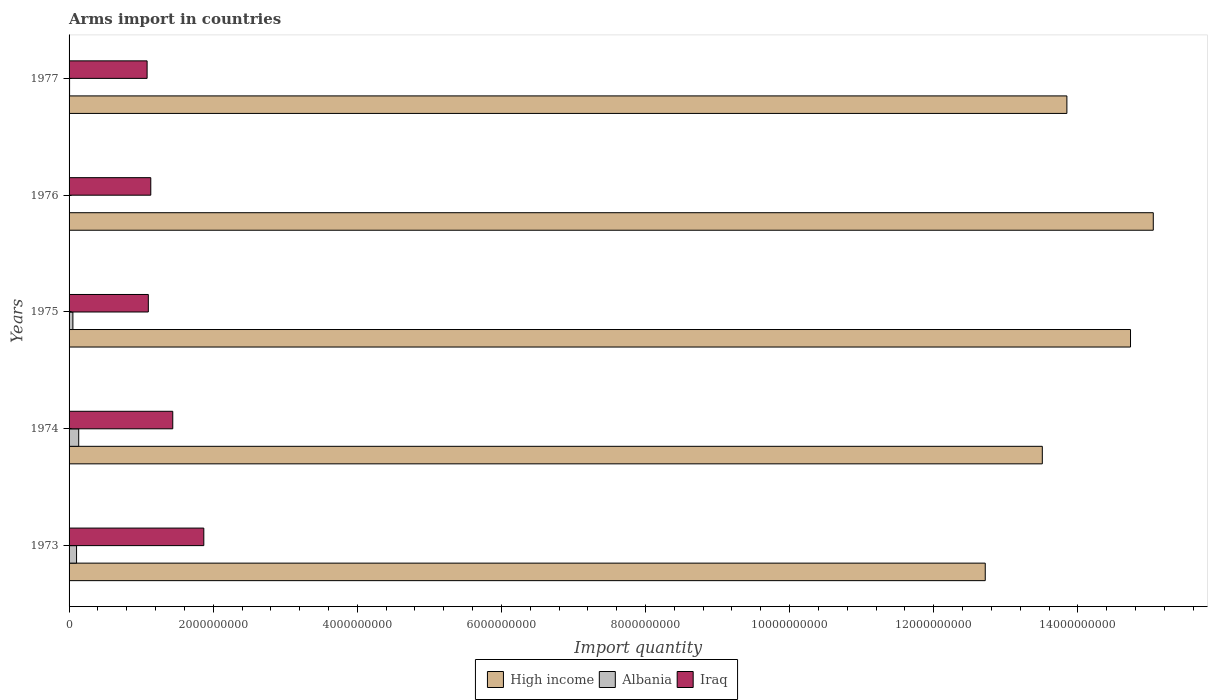How many groups of bars are there?
Your answer should be compact. 5. How many bars are there on the 5th tick from the top?
Provide a short and direct response. 3. How many bars are there on the 4th tick from the bottom?
Offer a terse response. 3. What is the label of the 4th group of bars from the top?
Your answer should be compact. 1974. In how many cases, is the number of bars for a given year not equal to the number of legend labels?
Make the answer very short. 0. What is the total arms import in High income in 1975?
Your answer should be compact. 1.47e+1. Across all years, what is the maximum total arms import in Iraq?
Your answer should be compact. 1.87e+09. Across all years, what is the minimum total arms import in High income?
Offer a terse response. 1.27e+1. In which year was the total arms import in Iraq maximum?
Keep it short and to the point. 1973. In which year was the total arms import in Albania minimum?
Offer a terse response. 1976. What is the total total arms import in High income in the graph?
Give a very brief answer. 6.98e+1. What is the difference between the total arms import in High income in 1973 and that in 1977?
Give a very brief answer. -1.13e+09. What is the difference between the total arms import in Iraq in 1977 and the total arms import in Albania in 1973?
Give a very brief answer. 9.79e+08. What is the average total arms import in Iraq per year?
Make the answer very short. 1.33e+09. In the year 1976, what is the difference between the total arms import in Iraq and total arms import in High income?
Provide a succinct answer. -1.39e+1. In how many years, is the total arms import in High income greater than 11600000000 ?
Ensure brevity in your answer.  5. What is the ratio of the total arms import in Albania in 1975 to that in 1976?
Ensure brevity in your answer.  10.6. What is the difference between the highest and the second highest total arms import in Albania?
Offer a very short reply. 3.00e+07. What is the difference between the highest and the lowest total arms import in High income?
Ensure brevity in your answer.  2.33e+09. In how many years, is the total arms import in Albania greater than the average total arms import in Albania taken over all years?
Your answer should be very brief. 2. What does the 1st bar from the top in 1973 represents?
Provide a short and direct response. Iraq. Is it the case that in every year, the sum of the total arms import in Iraq and total arms import in Albania is greater than the total arms import in High income?
Your answer should be compact. No. How many bars are there?
Provide a short and direct response. 15. Are all the bars in the graph horizontal?
Offer a terse response. Yes. Does the graph contain grids?
Keep it short and to the point. No. Where does the legend appear in the graph?
Make the answer very short. Bottom center. What is the title of the graph?
Your answer should be very brief. Arms import in countries. What is the label or title of the X-axis?
Ensure brevity in your answer.  Import quantity. What is the label or title of the Y-axis?
Your answer should be very brief. Years. What is the Import quantity in High income in 1973?
Provide a succinct answer. 1.27e+1. What is the Import quantity in Albania in 1973?
Provide a short and direct response. 1.04e+08. What is the Import quantity of Iraq in 1973?
Your response must be concise. 1.87e+09. What is the Import quantity of High income in 1974?
Your answer should be very brief. 1.35e+1. What is the Import quantity in Albania in 1974?
Your answer should be very brief. 1.34e+08. What is the Import quantity of Iraq in 1974?
Make the answer very short. 1.44e+09. What is the Import quantity of High income in 1975?
Provide a succinct answer. 1.47e+1. What is the Import quantity of Albania in 1975?
Give a very brief answer. 5.30e+07. What is the Import quantity of Iraq in 1975?
Your answer should be compact. 1.10e+09. What is the Import quantity of High income in 1976?
Give a very brief answer. 1.50e+1. What is the Import quantity in Iraq in 1976?
Make the answer very short. 1.13e+09. What is the Import quantity in High income in 1977?
Your answer should be very brief. 1.38e+1. What is the Import quantity in Albania in 1977?
Your answer should be very brief. 7.00e+06. What is the Import quantity of Iraq in 1977?
Provide a succinct answer. 1.08e+09. Across all years, what is the maximum Import quantity of High income?
Offer a terse response. 1.50e+1. Across all years, what is the maximum Import quantity in Albania?
Make the answer very short. 1.34e+08. Across all years, what is the maximum Import quantity in Iraq?
Your answer should be compact. 1.87e+09. Across all years, what is the minimum Import quantity in High income?
Provide a short and direct response. 1.27e+1. Across all years, what is the minimum Import quantity of Albania?
Ensure brevity in your answer.  5.00e+06. Across all years, what is the minimum Import quantity in Iraq?
Offer a terse response. 1.08e+09. What is the total Import quantity of High income in the graph?
Your answer should be compact. 6.98e+1. What is the total Import quantity in Albania in the graph?
Make the answer very short. 3.03e+08. What is the total Import quantity in Iraq in the graph?
Give a very brief answer. 6.63e+09. What is the difference between the Import quantity in High income in 1973 and that in 1974?
Offer a very short reply. -7.92e+08. What is the difference between the Import quantity of Albania in 1973 and that in 1974?
Keep it short and to the point. -3.00e+07. What is the difference between the Import quantity in Iraq in 1973 and that in 1974?
Ensure brevity in your answer.  4.31e+08. What is the difference between the Import quantity of High income in 1973 and that in 1975?
Make the answer very short. -2.02e+09. What is the difference between the Import quantity of Albania in 1973 and that in 1975?
Your answer should be very brief. 5.10e+07. What is the difference between the Import quantity of Iraq in 1973 and that in 1975?
Provide a short and direct response. 7.70e+08. What is the difference between the Import quantity in High income in 1973 and that in 1976?
Provide a short and direct response. -2.33e+09. What is the difference between the Import quantity of Albania in 1973 and that in 1976?
Offer a very short reply. 9.90e+07. What is the difference between the Import quantity of Iraq in 1973 and that in 1976?
Provide a succinct answer. 7.36e+08. What is the difference between the Import quantity of High income in 1973 and that in 1977?
Provide a short and direct response. -1.13e+09. What is the difference between the Import quantity of Albania in 1973 and that in 1977?
Provide a succinct answer. 9.70e+07. What is the difference between the Import quantity of Iraq in 1973 and that in 1977?
Keep it short and to the point. 7.87e+08. What is the difference between the Import quantity of High income in 1974 and that in 1975?
Keep it short and to the point. -1.22e+09. What is the difference between the Import quantity in Albania in 1974 and that in 1975?
Offer a very short reply. 8.10e+07. What is the difference between the Import quantity in Iraq in 1974 and that in 1975?
Your answer should be compact. 3.39e+08. What is the difference between the Import quantity in High income in 1974 and that in 1976?
Your answer should be very brief. -1.54e+09. What is the difference between the Import quantity of Albania in 1974 and that in 1976?
Keep it short and to the point. 1.29e+08. What is the difference between the Import quantity of Iraq in 1974 and that in 1976?
Offer a very short reply. 3.05e+08. What is the difference between the Import quantity of High income in 1974 and that in 1977?
Offer a very short reply. -3.41e+08. What is the difference between the Import quantity of Albania in 1974 and that in 1977?
Provide a succinct answer. 1.27e+08. What is the difference between the Import quantity in Iraq in 1974 and that in 1977?
Your response must be concise. 3.56e+08. What is the difference between the Import quantity in High income in 1975 and that in 1976?
Your response must be concise. -3.16e+08. What is the difference between the Import quantity in Albania in 1975 and that in 1976?
Your answer should be compact. 4.80e+07. What is the difference between the Import quantity in Iraq in 1975 and that in 1976?
Make the answer very short. -3.40e+07. What is the difference between the Import quantity of High income in 1975 and that in 1977?
Provide a succinct answer. 8.83e+08. What is the difference between the Import quantity of Albania in 1975 and that in 1977?
Provide a short and direct response. 4.60e+07. What is the difference between the Import quantity in Iraq in 1975 and that in 1977?
Keep it short and to the point. 1.70e+07. What is the difference between the Import quantity in High income in 1976 and that in 1977?
Ensure brevity in your answer.  1.20e+09. What is the difference between the Import quantity in Iraq in 1976 and that in 1977?
Keep it short and to the point. 5.10e+07. What is the difference between the Import quantity of High income in 1973 and the Import quantity of Albania in 1974?
Offer a very short reply. 1.26e+1. What is the difference between the Import quantity in High income in 1973 and the Import quantity in Iraq in 1974?
Give a very brief answer. 1.13e+1. What is the difference between the Import quantity in Albania in 1973 and the Import quantity in Iraq in 1974?
Give a very brief answer. -1.34e+09. What is the difference between the Import quantity in High income in 1973 and the Import quantity in Albania in 1975?
Provide a short and direct response. 1.27e+1. What is the difference between the Import quantity of High income in 1973 and the Import quantity of Iraq in 1975?
Your answer should be compact. 1.16e+1. What is the difference between the Import quantity of Albania in 1973 and the Import quantity of Iraq in 1975?
Offer a terse response. -9.96e+08. What is the difference between the Import quantity of High income in 1973 and the Import quantity of Albania in 1976?
Ensure brevity in your answer.  1.27e+1. What is the difference between the Import quantity of High income in 1973 and the Import quantity of Iraq in 1976?
Ensure brevity in your answer.  1.16e+1. What is the difference between the Import quantity in Albania in 1973 and the Import quantity in Iraq in 1976?
Keep it short and to the point. -1.03e+09. What is the difference between the Import quantity of High income in 1973 and the Import quantity of Albania in 1977?
Keep it short and to the point. 1.27e+1. What is the difference between the Import quantity in High income in 1973 and the Import quantity in Iraq in 1977?
Provide a succinct answer. 1.16e+1. What is the difference between the Import quantity of Albania in 1973 and the Import quantity of Iraq in 1977?
Provide a succinct answer. -9.79e+08. What is the difference between the Import quantity of High income in 1974 and the Import quantity of Albania in 1975?
Offer a terse response. 1.35e+1. What is the difference between the Import quantity of High income in 1974 and the Import quantity of Iraq in 1975?
Provide a succinct answer. 1.24e+1. What is the difference between the Import quantity of Albania in 1974 and the Import quantity of Iraq in 1975?
Offer a very short reply. -9.66e+08. What is the difference between the Import quantity of High income in 1974 and the Import quantity of Albania in 1976?
Your answer should be compact. 1.35e+1. What is the difference between the Import quantity in High income in 1974 and the Import quantity in Iraq in 1976?
Ensure brevity in your answer.  1.24e+1. What is the difference between the Import quantity of Albania in 1974 and the Import quantity of Iraq in 1976?
Keep it short and to the point. -1.00e+09. What is the difference between the Import quantity in High income in 1974 and the Import quantity in Albania in 1977?
Your response must be concise. 1.35e+1. What is the difference between the Import quantity in High income in 1974 and the Import quantity in Iraq in 1977?
Provide a succinct answer. 1.24e+1. What is the difference between the Import quantity in Albania in 1974 and the Import quantity in Iraq in 1977?
Make the answer very short. -9.49e+08. What is the difference between the Import quantity of High income in 1975 and the Import quantity of Albania in 1976?
Offer a very short reply. 1.47e+1. What is the difference between the Import quantity of High income in 1975 and the Import quantity of Iraq in 1976?
Provide a succinct answer. 1.36e+1. What is the difference between the Import quantity of Albania in 1975 and the Import quantity of Iraq in 1976?
Provide a short and direct response. -1.08e+09. What is the difference between the Import quantity of High income in 1975 and the Import quantity of Albania in 1977?
Your answer should be very brief. 1.47e+1. What is the difference between the Import quantity in High income in 1975 and the Import quantity in Iraq in 1977?
Offer a very short reply. 1.36e+1. What is the difference between the Import quantity in Albania in 1975 and the Import quantity in Iraq in 1977?
Your response must be concise. -1.03e+09. What is the difference between the Import quantity of High income in 1976 and the Import quantity of Albania in 1977?
Provide a succinct answer. 1.50e+1. What is the difference between the Import quantity in High income in 1976 and the Import quantity in Iraq in 1977?
Ensure brevity in your answer.  1.40e+1. What is the difference between the Import quantity in Albania in 1976 and the Import quantity in Iraq in 1977?
Your answer should be compact. -1.08e+09. What is the average Import quantity in High income per year?
Ensure brevity in your answer.  1.40e+1. What is the average Import quantity in Albania per year?
Offer a terse response. 6.06e+07. What is the average Import quantity of Iraq per year?
Your response must be concise. 1.33e+09. In the year 1973, what is the difference between the Import quantity of High income and Import quantity of Albania?
Provide a succinct answer. 1.26e+1. In the year 1973, what is the difference between the Import quantity in High income and Import quantity in Iraq?
Ensure brevity in your answer.  1.08e+1. In the year 1973, what is the difference between the Import quantity in Albania and Import quantity in Iraq?
Your response must be concise. -1.77e+09. In the year 1974, what is the difference between the Import quantity of High income and Import quantity of Albania?
Provide a succinct answer. 1.34e+1. In the year 1974, what is the difference between the Import quantity in High income and Import quantity in Iraq?
Give a very brief answer. 1.21e+1. In the year 1974, what is the difference between the Import quantity of Albania and Import quantity of Iraq?
Offer a terse response. -1.30e+09. In the year 1975, what is the difference between the Import quantity of High income and Import quantity of Albania?
Ensure brevity in your answer.  1.47e+1. In the year 1975, what is the difference between the Import quantity in High income and Import quantity in Iraq?
Your answer should be very brief. 1.36e+1. In the year 1975, what is the difference between the Import quantity in Albania and Import quantity in Iraq?
Give a very brief answer. -1.05e+09. In the year 1976, what is the difference between the Import quantity of High income and Import quantity of Albania?
Offer a terse response. 1.50e+1. In the year 1976, what is the difference between the Import quantity in High income and Import quantity in Iraq?
Keep it short and to the point. 1.39e+1. In the year 1976, what is the difference between the Import quantity of Albania and Import quantity of Iraq?
Keep it short and to the point. -1.13e+09. In the year 1977, what is the difference between the Import quantity of High income and Import quantity of Albania?
Make the answer very short. 1.38e+1. In the year 1977, what is the difference between the Import quantity of High income and Import quantity of Iraq?
Your answer should be compact. 1.28e+1. In the year 1977, what is the difference between the Import quantity of Albania and Import quantity of Iraq?
Offer a terse response. -1.08e+09. What is the ratio of the Import quantity of High income in 1973 to that in 1974?
Your answer should be compact. 0.94. What is the ratio of the Import quantity of Albania in 1973 to that in 1974?
Give a very brief answer. 0.78. What is the ratio of the Import quantity of Iraq in 1973 to that in 1974?
Your answer should be very brief. 1.3. What is the ratio of the Import quantity of High income in 1973 to that in 1975?
Your answer should be very brief. 0.86. What is the ratio of the Import quantity of Albania in 1973 to that in 1975?
Ensure brevity in your answer.  1.96. What is the ratio of the Import quantity in High income in 1973 to that in 1976?
Your answer should be compact. 0.84. What is the ratio of the Import quantity of Albania in 1973 to that in 1976?
Your response must be concise. 20.8. What is the ratio of the Import quantity of Iraq in 1973 to that in 1976?
Provide a succinct answer. 1.65. What is the ratio of the Import quantity in High income in 1973 to that in 1977?
Your answer should be very brief. 0.92. What is the ratio of the Import quantity in Albania in 1973 to that in 1977?
Offer a terse response. 14.86. What is the ratio of the Import quantity of Iraq in 1973 to that in 1977?
Make the answer very short. 1.73. What is the ratio of the Import quantity of High income in 1974 to that in 1975?
Your response must be concise. 0.92. What is the ratio of the Import quantity of Albania in 1974 to that in 1975?
Make the answer very short. 2.53. What is the ratio of the Import quantity in Iraq in 1974 to that in 1975?
Your answer should be very brief. 1.31. What is the ratio of the Import quantity of High income in 1974 to that in 1976?
Keep it short and to the point. 0.9. What is the ratio of the Import quantity in Albania in 1974 to that in 1976?
Offer a very short reply. 26.8. What is the ratio of the Import quantity in Iraq in 1974 to that in 1976?
Your response must be concise. 1.27. What is the ratio of the Import quantity of High income in 1974 to that in 1977?
Make the answer very short. 0.98. What is the ratio of the Import quantity in Albania in 1974 to that in 1977?
Provide a short and direct response. 19.14. What is the ratio of the Import quantity of Iraq in 1974 to that in 1977?
Offer a terse response. 1.33. What is the ratio of the Import quantity of Iraq in 1975 to that in 1976?
Provide a short and direct response. 0.97. What is the ratio of the Import quantity in High income in 1975 to that in 1977?
Your answer should be very brief. 1.06. What is the ratio of the Import quantity in Albania in 1975 to that in 1977?
Offer a terse response. 7.57. What is the ratio of the Import quantity in Iraq in 1975 to that in 1977?
Offer a terse response. 1.02. What is the ratio of the Import quantity of High income in 1976 to that in 1977?
Offer a terse response. 1.09. What is the ratio of the Import quantity of Iraq in 1976 to that in 1977?
Your answer should be compact. 1.05. What is the difference between the highest and the second highest Import quantity of High income?
Provide a short and direct response. 3.16e+08. What is the difference between the highest and the second highest Import quantity of Albania?
Keep it short and to the point. 3.00e+07. What is the difference between the highest and the second highest Import quantity of Iraq?
Offer a very short reply. 4.31e+08. What is the difference between the highest and the lowest Import quantity of High income?
Give a very brief answer. 2.33e+09. What is the difference between the highest and the lowest Import quantity in Albania?
Give a very brief answer. 1.29e+08. What is the difference between the highest and the lowest Import quantity in Iraq?
Your response must be concise. 7.87e+08. 